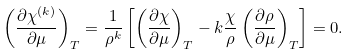<formula> <loc_0><loc_0><loc_500><loc_500>\left ( \frac { \partial \chi ^ { ( k ) } } { \partial \mu } \right ) _ { T } = \frac { 1 } { \rho ^ { k } } \left [ \left ( \frac { \partial \chi } { \partial \mu } \right ) _ { T } - k \frac { \chi } { \rho } \left ( \frac { \partial \rho } { \partial \mu } \right ) _ { T } \right ] = 0 .</formula> 